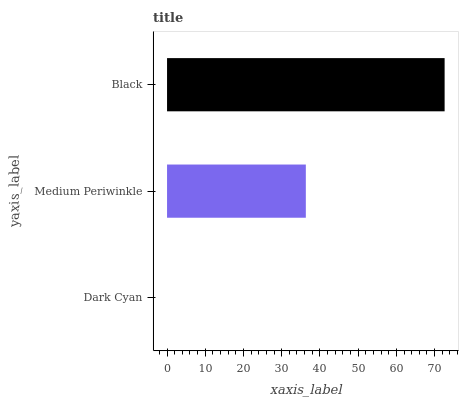Is Dark Cyan the minimum?
Answer yes or no. Yes. Is Black the maximum?
Answer yes or no. Yes. Is Medium Periwinkle the minimum?
Answer yes or no. No. Is Medium Periwinkle the maximum?
Answer yes or no. No. Is Medium Periwinkle greater than Dark Cyan?
Answer yes or no. Yes. Is Dark Cyan less than Medium Periwinkle?
Answer yes or no. Yes. Is Dark Cyan greater than Medium Periwinkle?
Answer yes or no. No. Is Medium Periwinkle less than Dark Cyan?
Answer yes or no. No. Is Medium Periwinkle the high median?
Answer yes or no. Yes. Is Medium Periwinkle the low median?
Answer yes or no. Yes. Is Dark Cyan the high median?
Answer yes or no. No. Is Black the low median?
Answer yes or no. No. 